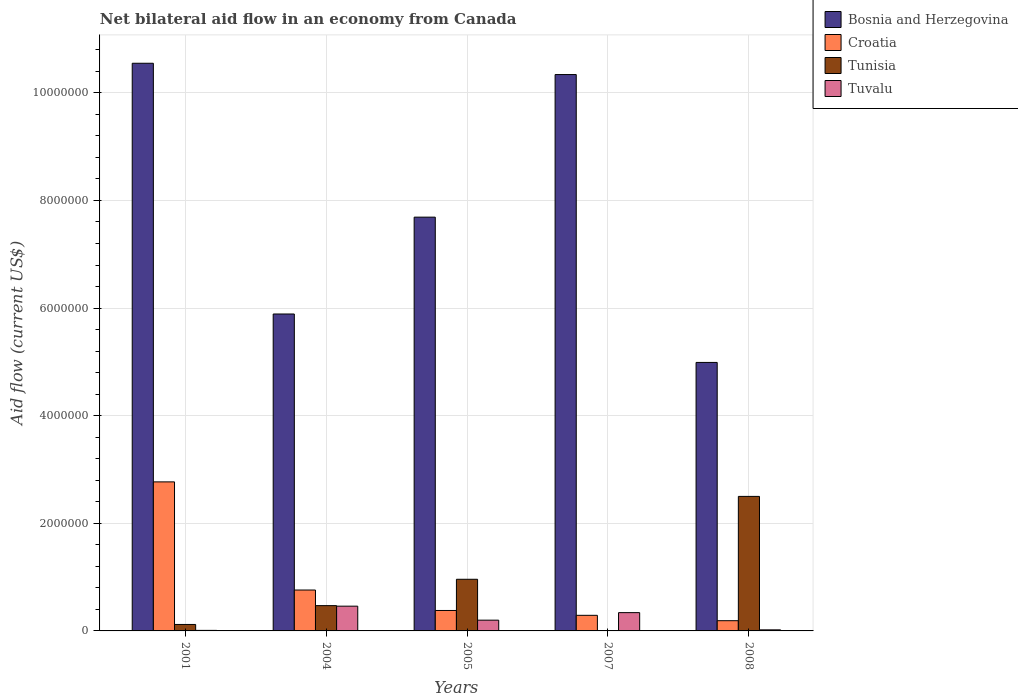How many different coloured bars are there?
Ensure brevity in your answer.  4. How many groups of bars are there?
Your answer should be compact. 5. Are the number of bars on each tick of the X-axis equal?
Provide a short and direct response. No. How many bars are there on the 3rd tick from the left?
Ensure brevity in your answer.  4. What is the net bilateral aid flow in Tunisia in 2007?
Your answer should be compact. 0. Across all years, what is the minimum net bilateral aid flow in Croatia?
Make the answer very short. 1.90e+05. What is the total net bilateral aid flow in Croatia in the graph?
Your answer should be very brief. 4.39e+06. What is the difference between the net bilateral aid flow in Tunisia in 2004 and that in 2008?
Your answer should be very brief. -2.03e+06. What is the difference between the net bilateral aid flow in Tunisia in 2007 and the net bilateral aid flow in Tuvalu in 2001?
Your answer should be compact. -10000. What is the average net bilateral aid flow in Tuvalu per year?
Ensure brevity in your answer.  2.06e+05. In the year 2005, what is the difference between the net bilateral aid flow in Croatia and net bilateral aid flow in Bosnia and Herzegovina?
Keep it short and to the point. -7.31e+06. What is the ratio of the net bilateral aid flow in Tuvalu in 2001 to that in 2004?
Provide a succinct answer. 0.02. Is the net bilateral aid flow in Tunisia in 2005 less than that in 2008?
Offer a very short reply. Yes. What is the difference between the highest and the second highest net bilateral aid flow in Tunisia?
Offer a terse response. 1.54e+06. What is the difference between the highest and the lowest net bilateral aid flow in Tunisia?
Provide a short and direct response. 2.50e+06. Is the sum of the net bilateral aid flow in Croatia in 2001 and 2007 greater than the maximum net bilateral aid flow in Bosnia and Herzegovina across all years?
Keep it short and to the point. No. Is it the case that in every year, the sum of the net bilateral aid flow in Tunisia and net bilateral aid flow in Tuvalu is greater than the sum of net bilateral aid flow in Croatia and net bilateral aid flow in Bosnia and Herzegovina?
Keep it short and to the point. No. Are the values on the major ticks of Y-axis written in scientific E-notation?
Ensure brevity in your answer.  No. Where does the legend appear in the graph?
Your answer should be compact. Top right. How many legend labels are there?
Make the answer very short. 4. What is the title of the graph?
Offer a terse response. Net bilateral aid flow in an economy from Canada. What is the label or title of the X-axis?
Your answer should be compact. Years. What is the label or title of the Y-axis?
Provide a succinct answer. Aid flow (current US$). What is the Aid flow (current US$) of Bosnia and Herzegovina in 2001?
Provide a short and direct response. 1.06e+07. What is the Aid flow (current US$) of Croatia in 2001?
Keep it short and to the point. 2.77e+06. What is the Aid flow (current US$) of Tunisia in 2001?
Your answer should be compact. 1.20e+05. What is the Aid flow (current US$) of Bosnia and Herzegovina in 2004?
Give a very brief answer. 5.89e+06. What is the Aid flow (current US$) in Croatia in 2004?
Your answer should be compact. 7.60e+05. What is the Aid flow (current US$) of Tunisia in 2004?
Your answer should be compact. 4.70e+05. What is the Aid flow (current US$) of Tuvalu in 2004?
Your response must be concise. 4.60e+05. What is the Aid flow (current US$) of Bosnia and Herzegovina in 2005?
Ensure brevity in your answer.  7.69e+06. What is the Aid flow (current US$) of Tunisia in 2005?
Offer a terse response. 9.60e+05. What is the Aid flow (current US$) of Bosnia and Herzegovina in 2007?
Keep it short and to the point. 1.03e+07. What is the Aid flow (current US$) in Tunisia in 2007?
Keep it short and to the point. 0. What is the Aid flow (current US$) of Bosnia and Herzegovina in 2008?
Make the answer very short. 4.99e+06. What is the Aid flow (current US$) in Croatia in 2008?
Ensure brevity in your answer.  1.90e+05. What is the Aid flow (current US$) of Tunisia in 2008?
Your answer should be very brief. 2.50e+06. What is the Aid flow (current US$) in Tuvalu in 2008?
Offer a very short reply. 2.00e+04. Across all years, what is the maximum Aid flow (current US$) of Bosnia and Herzegovina?
Your answer should be very brief. 1.06e+07. Across all years, what is the maximum Aid flow (current US$) in Croatia?
Provide a succinct answer. 2.77e+06. Across all years, what is the maximum Aid flow (current US$) of Tunisia?
Your response must be concise. 2.50e+06. Across all years, what is the maximum Aid flow (current US$) in Tuvalu?
Give a very brief answer. 4.60e+05. Across all years, what is the minimum Aid flow (current US$) in Bosnia and Herzegovina?
Provide a short and direct response. 4.99e+06. Across all years, what is the minimum Aid flow (current US$) in Tuvalu?
Make the answer very short. 10000. What is the total Aid flow (current US$) in Bosnia and Herzegovina in the graph?
Provide a succinct answer. 3.95e+07. What is the total Aid flow (current US$) in Croatia in the graph?
Your answer should be very brief. 4.39e+06. What is the total Aid flow (current US$) in Tunisia in the graph?
Your answer should be compact. 4.05e+06. What is the total Aid flow (current US$) of Tuvalu in the graph?
Your response must be concise. 1.03e+06. What is the difference between the Aid flow (current US$) in Bosnia and Herzegovina in 2001 and that in 2004?
Provide a short and direct response. 4.66e+06. What is the difference between the Aid flow (current US$) of Croatia in 2001 and that in 2004?
Ensure brevity in your answer.  2.01e+06. What is the difference between the Aid flow (current US$) of Tunisia in 2001 and that in 2004?
Make the answer very short. -3.50e+05. What is the difference between the Aid flow (current US$) of Tuvalu in 2001 and that in 2004?
Make the answer very short. -4.50e+05. What is the difference between the Aid flow (current US$) of Bosnia and Herzegovina in 2001 and that in 2005?
Your answer should be compact. 2.86e+06. What is the difference between the Aid flow (current US$) of Croatia in 2001 and that in 2005?
Your answer should be very brief. 2.39e+06. What is the difference between the Aid flow (current US$) in Tunisia in 2001 and that in 2005?
Your response must be concise. -8.40e+05. What is the difference between the Aid flow (current US$) of Tuvalu in 2001 and that in 2005?
Your answer should be compact. -1.90e+05. What is the difference between the Aid flow (current US$) of Bosnia and Herzegovina in 2001 and that in 2007?
Your answer should be compact. 2.10e+05. What is the difference between the Aid flow (current US$) of Croatia in 2001 and that in 2007?
Offer a terse response. 2.48e+06. What is the difference between the Aid flow (current US$) in Tuvalu in 2001 and that in 2007?
Make the answer very short. -3.30e+05. What is the difference between the Aid flow (current US$) of Bosnia and Herzegovina in 2001 and that in 2008?
Ensure brevity in your answer.  5.56e+06. What is the difference between the Aid flow (current US$) of Croatia in 2001 and that in 2008?
Provide a succinct answer. 2.58e+06. What is the difference between the Aid flow (current US$) in Tunisia in 2001 and that in 2008?
Keep it short and to the point. -2.38e+06. What is the difference between the Aid flow (current US$) of Tuvalu in 2001 and that in 2008?
Provide a succinct answer. -10000. What is the difference between the Aid flow (current US$) of Bosnia and Herzegovina in 2004 and that in 2005?
Your answer should be compact. -1.80e+06. What is the difference between the Aid flow (current US$) in Tunisia in 2004 and that in 2005?
Keep it short and to the point. -4.90e+05. What is the difference between the Aid flow (current US$) of Bosnia and Herzegovina in 2004 and that in 2007?
Keep it short and to the point. -4.45e+06. What is the difference between the Aid flow (current US$) in Croatia in 2004 and that in 2007?
Offer a terse response. 4.70e+05. What is the difference between the Aid flow (current US$) of Tuvalu in 2004 and that in 2007?
Make the answer very short. 1.20e+05. What is the difference between the Aid flow (current US$) in Croatia in 2004 and that in 2008?
Offer a terse response. 5.70e+05. What is the difference between the Aid flow (current US$) of Tunisia in 2004 and that in 2008?
Ensure brevity in your answer.  -2.03e+06. What is the difference between the Aid flow (current US$) of Tuvalu in 2004 and that in 2008?
Provide a succinct answer. 4.40e+05. What is the difference between the Aid flow (current US$) in Bosnia and Herzegovina in 2005 and that in 2007?
Offer a terse response. -2.65e+06. What is the difference between the Aid flow (current US$) in Croatia in 2005 and that in 2007?
Your answer should be compact. 9.00e+04. What is the difference between the Aid flow (current US$) of Bosnia and Herzegovina in 2005 and that in 2008?
Offer a terse response. 2.70e+06. What is the difference between the Aid flow (current US$) of Croatia in 2005 and that in 2008?
Your answer should be very brief. 1.90e+05. What is the difference between the Aid flow (current US$) of Tunisia in 2005 and that in 2008?
Offer a terse response. -1.54e+06. What is the difference between the Aid flow (current US$) of Tuvalu in 2005 and that in 2008?
Offer a very short reply. 1.80e+05. What is the difference between the Aid flow (current US$) of Bosnia and Herzegovina in 2007 and that in 2008?
Provide a short and direct response. 5.35e+06. What is the difference between the Aid flow (current US$) of Bosnia and Herzegovina in 2001 and the Aid flow (current US$) of Croatia in 2004?
Give a very brief answer. 9.79e+06. What is the difference between the Aid flow (current US$) of Bosnia and Herzegovina in 2001 and the Aid flow (current US$) of Tunisia in 2004?
Ensure brevity in your answer.  1.01e+07. What is the difference between the Aid flow (current US$) in Bosnia and Herzegovina in 2001 and the Aid flow (current US$) in Tuvalu in 2004?
Your answer should be very brief. 1.01e+07. What is the difference between the Aid flow (current US$) in Croatia in 2001 and the Aid flow (current US$) in Tunisia in 2004?
Your answer should be very brief. 2.30e+06. What is the difference between the Aid flow (current US$) in Croatia in 2001 and the Aid flow (current US$) in Tuvalu in 2004?
Your answer should be very brief. 2.31e+06. What is the difference between the Aid flow (current US$) of Tunisia in 2001 and the Aid flow (current US$) of Tuvalu in 2004?
Give a very brief answer. -3.40e+05. What is the difference between the Aid flow (current US$) of Bosnia and Herzegovina in 2001 and the Aid flow (current US$) of Croatia in 2005?
Offer a terse response. 1.02e+07. What is the difference between the Aid flow (current US$) in Bosnia and Herzegovina in 2001 and the Aid flow (current US$) in Tunisia in 2005?
Your answer should be very brief. 9.59e+06. What is the difference between the Aid flow (current US$) in Bosnia and Herzegovina in 2001 and the Aid flow (current US$) in Tuvalu in 2005?
Offer a terse response. 1.04e+07. What is the difference between the Aid flow (current US$) of Croatia in 2001 and the Aid flow (current US$) of Tunisia in 2005?
Make the answer very short. 1.81e+06. What is the difference between the Aid flow (current US$) in Croatia in 2001 and the Aid flow (current US$) in Tuvalu in 2005?
Give a very brief answer. 2.57e+06. What is the difference between the Aid flow (current US$) in Bosnia and Herzegovina in 2001 and the Aid flow (current US$) in Croatia in 2007?
Ensure brevity in your answer.  1.03e+07. What is the difference between the Aid flow (current US$) of Bosnia and Herzegovina in 2001 and the Aid flow (current US$) of Tuvalu in 2007?
Provide a short and direct response. 1.02e+07. What is the difference between the Aid flow (current US$) in Croatia in 2001 and the Aid flow (current US$) in Tuvalu in 2007?
Ensure brevity in your answer.  2.43e+06. What is the difference between the Aid flow (current US$) of Tunisia in 2001 and the Aid flow (current US$) of Tuvalu in 2007?
Ensure brevity in your answer.  -2.20e+05. What is the difference between the Aid flow (current US$) in Bosnia and Herzegovina in 2001 and the Aid flow (current US$) in Croatia in 2008?
Your answer should be compact. 1.04e+07. What is the difference between the Aid flow (current US$) of Bosnia and Herzegovina in 2001 and the Aid flow (current US$) of Tunisia in 2008?
Make the answer very short. 8.05e+06. What is the difference between the Aid flow (current US$) of Bosnia and Herzegovina in 2001 and the Aid flow (current US$) of Tuvalu in 2008?
Ensure brevity in your answer.  1.05e+07. What is the difference between the Aid flow (current US$) in Croatia in 2001 and the Aid flow (current US$) in Tuvalu in 2008?
Your answer should be compact. 2.75e+06. What is the difference between the Aid flow (current US$) of Tunisia in 2001 and the Aid flow (current US$) of Tuvalu in 2008?
Offer a very short reply. 1.00e+05. What is the difference between the Aid flow (current US$) in Bosnia and Herzegovina in 2004 and the Aid flow (current US$) in Croatia in 2005?
Give a very brief answer. 5.51e+06. What is the difference between the Aid flow (current US$) of Bosnia and Herzegovina in 2004 and the Aid flow (current US$) of Tunisia in 2005?
Provide a short and direct response. 4.93e+06. What is the difference between the Aid flow (current US$) of Bosnia and Herzegovina in 2004 and the Aid flow (current US$) of Tuvalu in 2005?
Provide a succinct answer. 5.69e+06. What is the difference between the Aid flow (current US$) in Croatia in 2004 and the Aid flow (current US$) in Tunisia in 2005?
Offer a very short reply. -2.00e+05. What is the difference between the Aid flow (current US$) of Croatia in 2004 and the Aid flow (current US$) of Tuvalu in 2005?
Provide a succinct answer. 5.60e+05. What is the difference between the Aid flow (current US$) of Bosnia and Herzegovina in 2004 and the Aid flow (current US$) of Croatia in 2007?
Your answer should be compact. 5.60e+06. What is the difference between the Aid flow (current US$) of Bosnia and Herzegovina in 2004 and the Aid flow (current US$) of Tuvalu in 2007?
Ensure brevity in your answer.  5.55e+06. What is the difference between the Aid flow (current US$) of Croatia in 2004 and the Aid flow (current US$) of Tuvalu in 2007?
Keep it short and to the point. 4.20e+05. What is the difference between the Aid flow (current US$) in Bosnia and Herzegovina in 2004 and the Aid flow (current US$) in Croatia in 2008?
Make the answer very short. 5.70e+06. What is the difference between the Aid flow (current US$) in Bosnia and Herzegovina in 2004 and the Aid flow (current US$) in Tunisia in 2008?
Give a very brief answer. 3.39e+06. What is the difference between the Aid flow (current US$) in Bosnia and Herzegovina in 2004 and the Aid flow (current US$) in Tuvalu in 2008?
Provide a short and direct response. 5.87e+06. What is the difference between the Aid flow (current US$) in Croatia in 2004 and the Aid flow (current US$) in Tunisia in 2008?
Offer a very short reply. -1.74e+06. What is the difference between the Aid flow (current US$) in Croatia in 2004 and the Aid flow (current US$) in Tuvalu in 2008?
Your answer should be very brief. 7.40e+05. What is the difference between the Aid flow (current US$) in Tunisia in 2004 and the Aid flow (current US$) in Tuvalu in 2008?
Give a very brief answer. 4.50e+05. What is the difference between the Aid flow (current US$) in Bosnia and Herzegovina in 2005 and the Aid flow (current US$) in Croatia in 2007?
Keep it short and to the point. 7.40e+06. What is the difference between the Aid flow (current US$) in Bosnia and Herzegovina in 2005 and the Aid flow (current US$) in Tuvalu in 2007?
Give a very brief answer. 7.35e+06. What is the difference between the Aid flow (current US$) in Tunisia in 2005 and the Aid flow (current US$) in Tuvalu in 2007?
Make the answer very short. 6.20e+05. What is the difference between the Aid flow (current US$) of Bosnia and Herzegovina in 2005 and the Aid flow (current US$) of Croatia in 2008?
Ensure brevity in your answer.  7.50e+06. What is the difference between the Aid flow (current US$) in Bosnia and Herzegovina in 2005 and the Aid flow (current US$) in Tunisia in 2008?
Provide a succinct answer. 5.19e+06. What is the difference between the Aid flow (current US$) in Bosnia and Herzegovina in 2005 and the Aid flow (current US$) in Tuvalu in 2008?
Your answer should be compact. 7.67e+06. What is the difference between the Aid flow (current US$) of Croatia in 2005 and the Aid flow (current US$) of Tunisia in 2008?
Provide a succinct answer. -2.12e+06. What is the difference between the Aid flow (current US$) of Croatia in 2005 and the Aid flow (current US$) of Tuvalu in 2008?
Provide a succinct answer. 3.60e+05. What is the difference between the Aid flow (current US$) of Tunisia in 2005 and the Aid flow (current US$) of Tuvalu in 2008?
Provide a short and direct response. 9.40e+05. What is the difference between the Aid flow (current US$) in Bosnia and Herzegovina in 2007 and the Aid flow (current US$) in Croatia in 2008?
Make the answer very short. 1.02e+07. What is the difference between the Aid flow (current US$) of Bosnia and Herzegovina in 2007 and the Aid flow (current US$) of Tunisia in 2008?
Your answer should be very brief. 7.84e+06. What is the difference between the Aid flow (current US$) of Bosnia and Herzegovina in 2007 and the Aid flow (current US$) of Tuvalu in 2008?
Your answer should be compact. 1.03e+07. What is the difference between the Aid flow (current US$) of Croatia in 2007 and the Aid flow (current US$) of Tunisia in 2008?
Give a very brief answer. -2.21e+06. What is the average Aid flow (current US$) in Bosnia and Herzegovina per year?
Give a very brief answer. 7.89e+06. What is the average Aid flow (current US$) in Croatia per year?
Ensure brevity in your answer.  8.78e+05. What is the average Aid flow (current US$) of Tunisia per year?
Keep it short and to the point. 8.10e+05. What is the average Aid flow (current US$) in Tuvalu per year?
Your answer should be compact. 2.06e+05. In the year 2001, what is the difference between the Aid flow (current US$) in Bosnia and Herzegovina and Aid flow (current US$) in Croatia?
Offer a terse response. 7.78e+06. In the year 2001, what is the difference between the Aid flow (current US$) in Bosnia and Herzegovina and Aid flow (current US$) in Tunisia?
Provide a short and direct response. 1.04e+07. In the year 2001, what is the difference between the Aid flow (current US$) in Bosnia and Herzegovina and Aid flow (current US$) in Tuvalu?
Provide a succinct answer. 1.05e+07. In the year 2001, what is the difference between the Aid flow (current US$) in Croatia and Aid flow (current US$) in Tunisia?
Your response must be concise. 2.65e+06. In the year 2001, what is the difference between the Aid flow (current US$) in Croatia and Aid flow (current US$) in Tuvalu?
Your answer should be compact. 2.76e+06. In the year 2001, what is the difference between the Aid flow (current US$) of Tunisia and Aid flow (current US$) of Tuvalu?
Make the answer very short. 1.10e+05. In the year 2004, what is the difference between the Aid flow (current US$) of Bosnia and Herzegovina and Aid flow (current US$) of Croatia?
Ensure brevity in your answer.  5.13e+06. In the year 2004, what is the difference between the Aid flow (current US$) in Bosnia and Herzegovina and Aid flow (current US$) in Tunisia?
Keep it short and to the point. 5.42e+06. In the year 2004, what is the difference between the Aid flow (current US$) of Bosnia and Herzegovina and Aid flow (current US$) of Tuvalu?
Your answer should be compact. 5.43e+06. In the year 2004, what is the difference between the Aid flow (current US$) of Croatia and Aid flow (current US$) of Tunisia?
Provide a short and direct response. 2.90e+05. In the year 2004, what is the difference between the Aid flow (current US$) of Croatia and Aid flow (current US$) of Tuvalu?
Ensure brevity in your answer.  3.00e+05. In the year 2005, what is the difference between the Aid flow (current US$) of Bosnia and Herzegovina and Aid flow (current US$) of Croatia?
Your answer should be very brief. 7.31e+06. In the year 2005, what is the difference between the Aid flow (current US$) in Bosnia and Herzegovina and Aid flow (current US$) in Tunisia?
Provide a short and direct response. 6.73e+06. In the year 2005, what is the difference between the Aid flow (current US$) in Bosnia and Herzegovina and Aid flow (current US$) in Tuvalu?
Offer a very short reply. 7.49e+06. In the year 2005, what is the difference between the Aid flow (current US$) in Croatia and Aid flow (current US$) in Tunisia?
Your response must be concise. -5.80e+05. In the year 2005, what is the difference between the Aid flow (current US$) in Tunisia and Aid flow (current US$) in Tuvalu?
Keep it short and to the point. 7.60e+05. In the year 2007, what is the difference between the Aid flow (current US$) in Bosnia and Herzegovina and Aid flow (current US$) in Croatia?
Provide a short and direct response. 1.00e+07. In the year 2007, what is the difference between the Aid flow (current US$) of Croatia and Aid flow (current US$) of Tuvalu?
Ensure brevity in your answer.  -5.00e+04. In the year 2008, what is the difference between the Aid flow (current US$) in Bosnia and Herzegovina and Aid flow (current US$) in Croatia?
Make the answer very short. 4.80e+06. In the year 2008, what is the difference between the Aid flow (current US$) in Bosnia and Herzegovina and Aid flow (current US$) in Tunisia?
Make the answer very short. 2.49e+06. In the year 2008, what is the difference between the Aid flow (current US$) in Bosnia and Herzegovina and Aid flow (current US$) in Tuvalu?
Your answer should be compact. 4.97e+06. In the year 2008, what is the difference between the Aid flow (current US$) of Croatia and Aid flow (current US$) of Tunisia?
Your response must be concise. -2.31e+06. In the year 2008, what is the difference between the Aid flow (current US$) in Tunisia and Aid flow (current US$) in Tuvalu?
Provide a short and direct response. 2.48e+06. What is the ratio of the Aid flow (current US$) in Bosnia and Herzegovina in 2001 to that in 2004?
Offer a terse response. 1.79. What is the ratio of the Aid flow (current US$) of Croatia in 2001 to that in 2004?
Provide a short and direct response. 3.64. What is the ratio of the Aid flow (current US$) of Tunisia in 2001 to that in 2004?
Offer a terse response. 0.26. What is the ratio of the Aid flow (current US$) in Tuvalu in 2001 to that in 2004?
Give a very brief answer. 0.02. What is the ratio of the Aid flow (current US$) of Bosnia and Herzegovina in 2001 to that in 2005?
Make the answer very short. 1.37. What is the ratio of the Aid flow (current US$) of Croatia in 2001 to that in 2005?
Offer a very short reply. 7.29. What is the ratio of the Aid flow (current US$) of Tunisia in 2001 to that in 2005?
Your answer should be compact. 0.12. What is the ratio of the Aid flow (current US$) of Tuvalu in 2001 to that in 2005?
Offer a terse response. 0.05. What is the ratio of the Aid flow (current US$) of Bosnia and Herzegovina in 2001 to that in 2007?
Provide a succinct answer. 1.02. What is the ratio of the Aid flow (current US$) of Croatia in 2001 to that in 2007?
Your answer should be very brief. 9.55. What is the ratio of the Aid flow (current US$) of Tuvalu in 2001 to that in 2007?
Offer a terse response. 0.03. What is the ratio of the Aid flow (current US$) of Bosnia and Herzegovina in 2001 to that in 2008?
Your answer should be compact. 2.11. What is the ratio of the Aid flow (current US$) in Croatia in 2001 to that in 2008?
Your answer should be compact. 14.58. What is the ratio of the Aid flow (current US$) of Tunisia in 2001 to that in 2008?
Offer a very short reply. 0.05. What is the ratio of the Aid flow (current US$) of Tuvalu in 2001 to that in 2008?
Your answer should be very brief. 0.5. What is the ratio of the Aid flow (current US$) of Bosnia and Herzegovina in 2004 to that in 2005?
Make the answer very short. 0.77. What is the ratio of the Aid flow (current US$) of Croatia in 2004 to that in 2005?
Keep it short and to the point. 2. What is the ratio of the Aid flow (current US$) of Tunisia in 2004 to that in 2005?
Your answer should be compact. 0.49. What is the ratio of the Aid flow (current US$) of Bosnia and Herzegovina in 2004 to that in 2007?
Your response must be concise. 0.57. What is the ratio of the Aid flow (current US$) of Croatia in 2004 to that in 2007?
Give a very brief answer. 2.62. What is the ratio of the Aid flow (current US$) of Tuvalu in 2004 to that in 2007?
Make the answer very short. 1.35. What is the ratio of the Aid flow (current US$) in Bosnia and Herzegovina in 2004 to that in 2008?
Make the answer very short. 1.18. What is the ratio of the Aid flow (current US$) in Tunisia in 2004 to that in 2008?
Ensure brevity in your answer.  0.19. What is the ratio of the Aid flow (current US$) of Bosnia and Herzegovina in 2005 to that in 2007?
Offer a terse response. 0.74. What is the ratio of the Aid flow (current US$) of Croatia in 2005 to that in 2007?
Your answer should be very brief. 1.31. What is the ratio of the Aid flow (current US$) in Tuvalu in 2005 to that in 2007?
Give a very brief answer. 0.59. What is the ratio of the Aid flow (current US$) in Bosnia and Herzegovina in 2005 to that in 2008?
Offer a very short reply. 1.54. What is the ratio of the Aid flow (current US$) in Croatia in 2005 to that in 2008?
Give a very brief answer. 2. What is the ratio of the Aid flow (current US$) of Tunisia in 2005 to that in 2008?
Give a very brief answer. 0.38. What is the ratio of the Aid flow (current US$) in Tuvalu in 2005 to that in 2008?
Ensure brevity in your answer.  10. What is the ratio of the Aid flow (current US$) in Bosnia and Herzegovina in 2007 to that in 2008?
Provide a short and direct response. 2.07. What is the ratio of the Aid flow (current US$) in Croatia in 2007 to that in 2008?
Give a very brief answer. 1.53. What is the ratio of the Aid flow (current US$) in Tuvalu in 2007 to that in 2008?
Your response must be concise. 17. What is the difference between the highest and the second highest Aid flow (current US$) of Croatia?
Your answer should be compact. 2.01e+06. What is the difference between the highest and the second highest Aid flow (current US$) in Tunisia?
Offer a terse response. 1.54e+06. What is the difference between the highest and the lowest Aid flow (current US$) in Bosnia and Herzegovina?
Offer a terse response. 5.56e+06. What is the difference between the highest and the lowest Aid flow (current US$) in Croatia?
Offer a terse response. 2.58e+06. What is the difference between the highest and the lowest Aid flow (current US$) in Tunisia?
Provide a succinct answer. 2.50e+06. What is the difference between the highest and the lowest Aid flow (current US$) in Tuvalu?
Provide a short and direct response. 4.50e+05. 